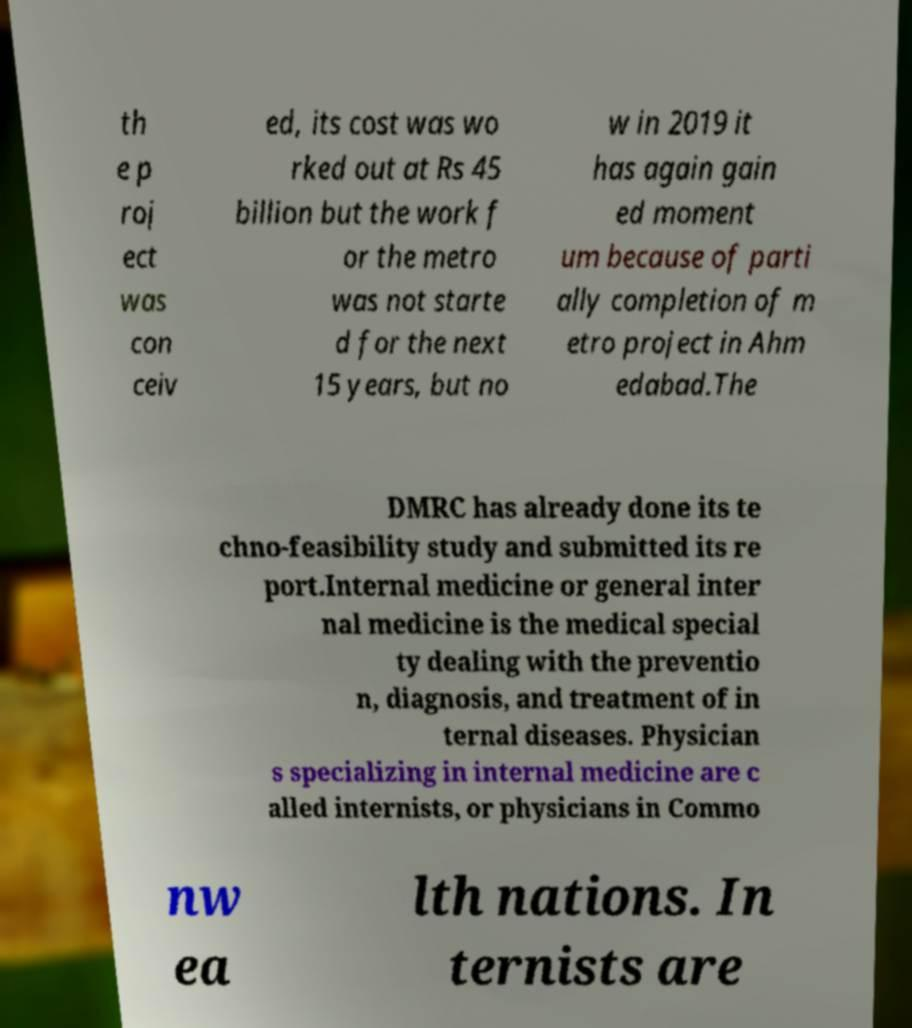Please read and relay the text visible in this image. What does it say? th e p roj ect was con ceiv ed, its cost was wo rked out at Rs 45 billion but the work f or the metro was not starte d for the next 15 years, but no w in 2019 it has again gain ed moment um because of parti ally completion of m etro project in Ahm edabad.The DMRC has already done its te chno-feasibility study and submitted its re port.Internal medicine or general inter nal medicine is the medical special ty dealing with the preventio n, diagnosis, and treatment of in ternal diseases. Physician s specializing in internal medicine are c alled internists, or physicians in Commo nw ea lth nations. In ternists are 